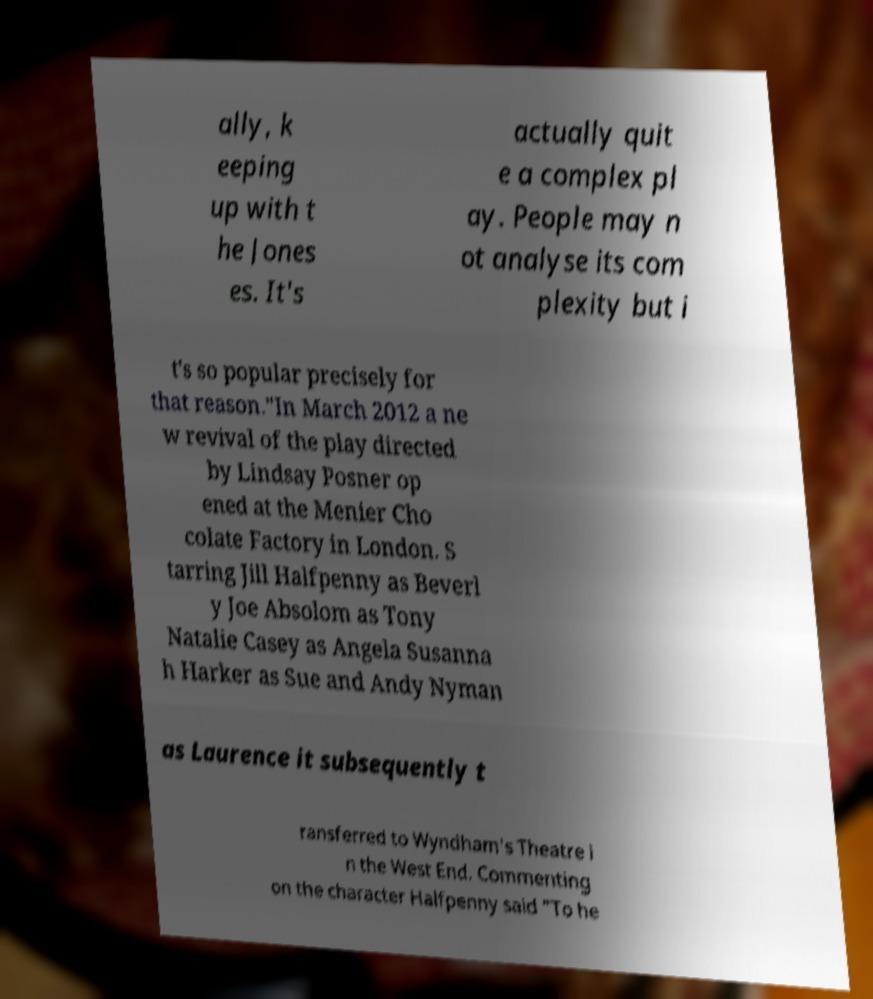What messages or text are displayed in this image? I need them in a readable, typed format. ally, k eeping up with t he Jones es. It's actually quit e a complex pl ay. People may n ot analyse its com plexity but i t's so popular precisely for that reason."In March 2012 a ne w revival of the play directed by Lindsay Posner op ened at the Menier Cho colate Factory in London. S tarring Jill Halfpenny as Beverl y Joe Absolom as Tony Natalie Casey as Angela Susanna h Harker as Sue and Andy Nyman as Laurence it subsequently t ransferred to Wyndham's Theatre i n the West End. Commenting on the character Halfpenny said "To he 